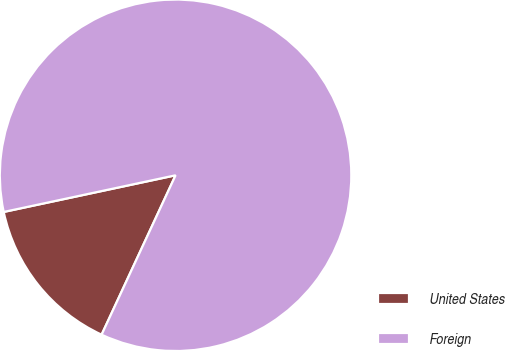Convert chart. <chart><loc_0><loc_0><loc_500><loc_500><pie_chart><fcel>United States<fcel>Foreign<nl><fcel>14.74%<fcel>85.26%<nl></chart> 